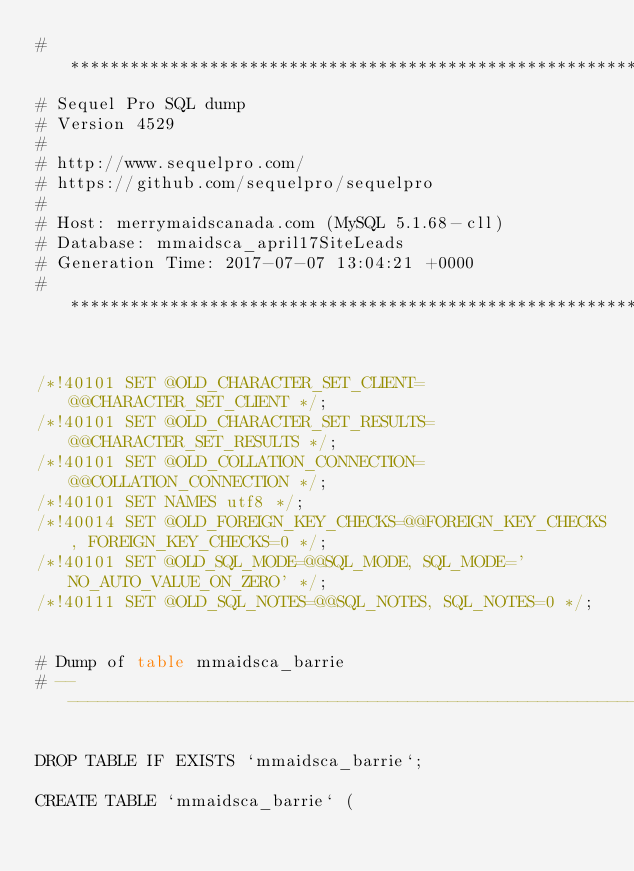Convert code to text. <code><loc_0><loc_0><loc_500><loc_500><_SQL_># ************************************************************
# Sequel Pro SQL dump
# Version 4529
#
# http://www.sequelpro.com/
# https://github.com/sequelpro/sequelpro
#
# Host: merrymaidscanada.com (MySQL 5.1.68-cll)
# Database: mmaidsca_april17SiteLeads
# Generation Time: 2017-07-07 13:04:21 +0000
# ************************************************************


/*!40101 SET @OLD_CHARACTER_SET_CLIENT=@@CHARACTER_SET_CLIENT */;
/*!40101 SET @OLD_CHARACTER_SET_RESULTS=@@CHARACTER_SET_RESULTS */;
/*!40101 SET @OLD_COLLATION_CONNECTION=@@COLLATION_CONNECTION */;
/*!40101 SET NAMES utf8 */;
/*!40014 SET @OLD_FOREIGN_KEY_CHECKS=@@FOREIGN_KEY_CHECKS, FOREIGN_KEY_CHECKS=0 */;
/*!40101 SET @OLD_SQL_MODE=@@SQL_MODE, SQL_MODE='NO_AUTO_VALUE_ON_ZERO' */;
/*!40111 SET @OLD_SQL_NOTES=@@SQL_NOTES, SQL_NOTES=0 */;


# Dump of table mmaidsca_barrie
# ------------------------------------------------------------

DROP TABLE IF EXISTS `mmaidsca_barrie`;

CREATE TABLE `mmaidsca_barrie` (</code> 